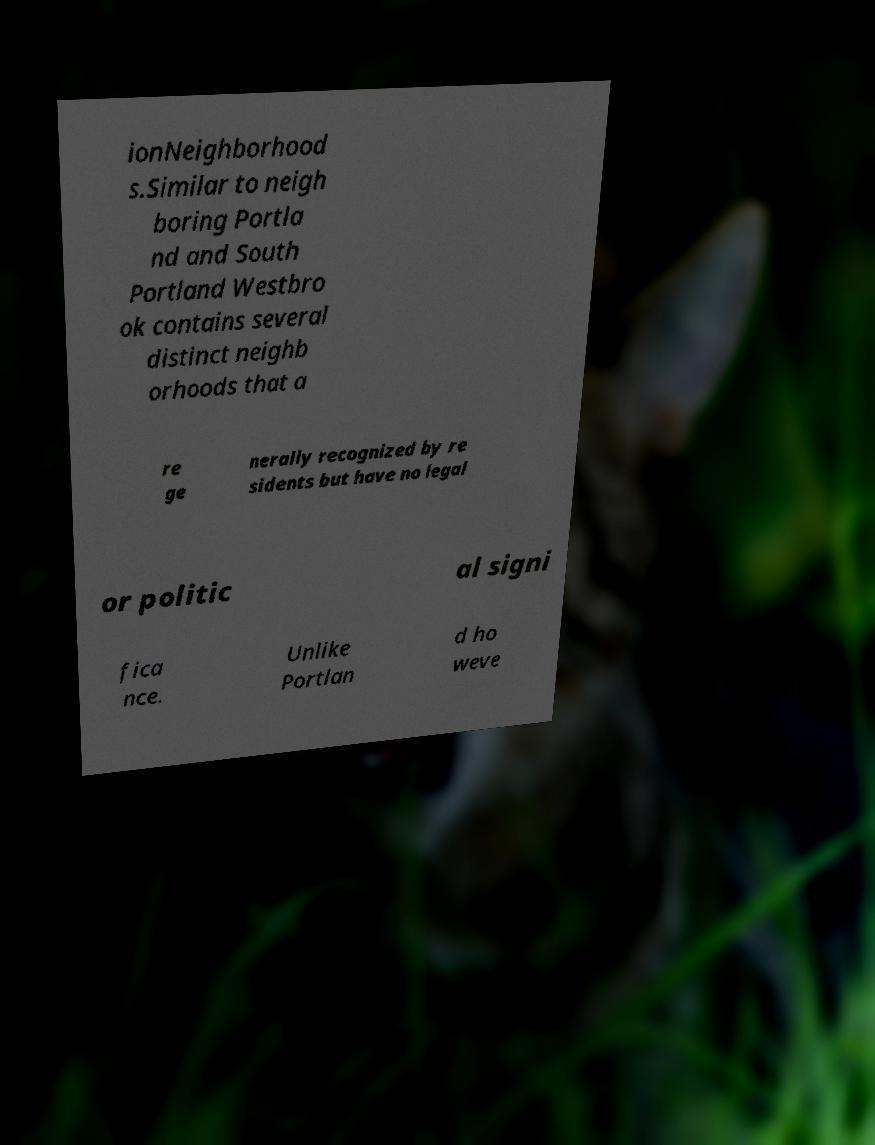I need the written content from this picture converted into text. Can you do that? ionNeighborhood s.Similar to neigh boring Portla nd and South Portland Westbro ok contains several distinct neighb orhoods that a re ge nerally recognized by re sidents but have no legal or politic al signi fica nce. Unlike Portlan d ho weve 